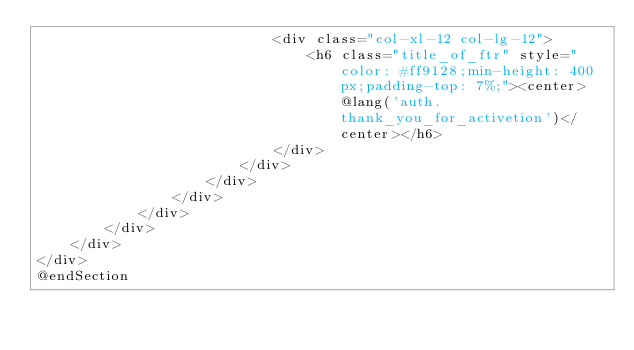Convert code to text. <code><loc_0><loc_0><loc_500><loc_500><_PHP_>                            <div class="col-xl-12 col-lg-12">
                                <h6 class="title_of_ftr" style="color: #ff9128;min-height: 400px;padding-top: 7%;"><center>@lang('auth.thank_you_for_activetion')</center></h6>
                            </div>
                        </div>
                    </div>
                </div>
            </div>
        </div>
    </div>
</div>
@endSection</code> 